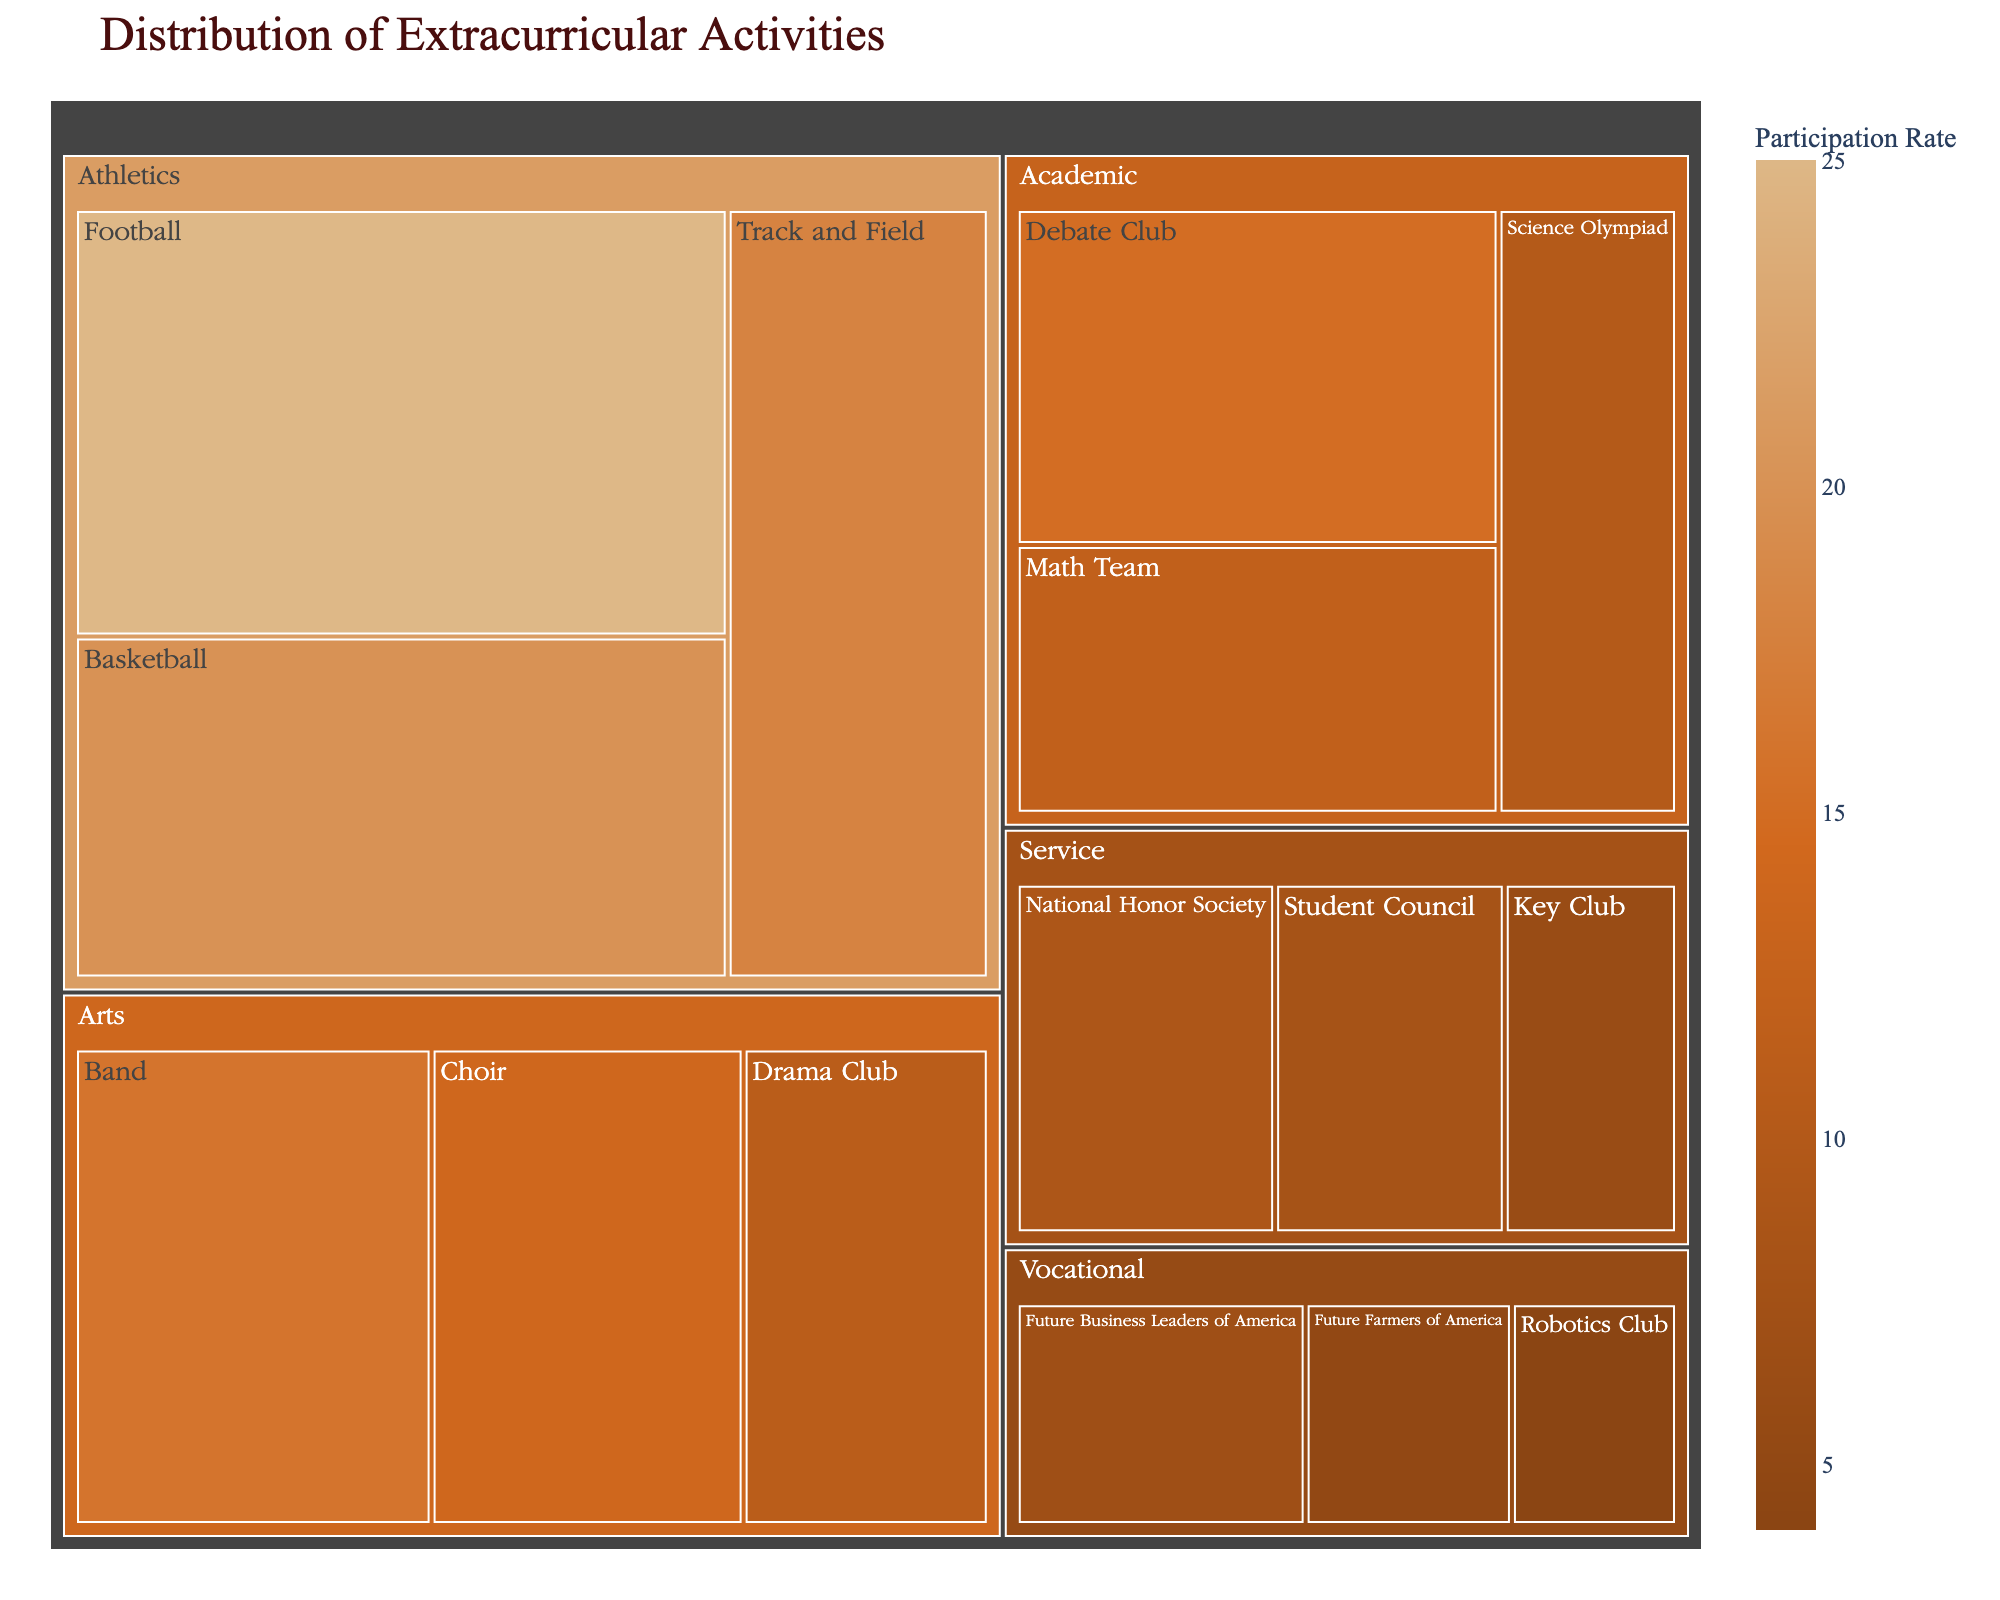What is the title of the treemap? The title of the treemap is typically located at the top of the figure, displaying the subject of the treemap.
Answer: Distribution of Extracurricular Activities Which category has the highest participation rate? One must identify the largest proportional area within the treemap and note its corresponding category. The 'Athletics' category fills the largest portion of the treemap.
Answer: Athletics Out of the Athletic subcategories, which has the highest participation rate? To find the highest participation rate within Athletics, look at the relative sizes of the subcategories under the Athletics section and identify the largest one. Football has the largest area under Athletics.
Answer: Football What is the participation rate for the Drama Club? Locate the Drama Club subcategory within the Arts category on the treemap and refer to the participation rate indicated.
Answer: 11% What is the combined participation rate for the Debate Club and Math Team? Add the participation rates of the Debate Club (15) and Math Team (12) together. 15 + 12 = 27
Answer: 27% Which category has both the largest and smallest subcategories in terms of participation rate? Observe the treemap for the category that contains both the largest (Football in Athletics) and the smallest (Robotics Club in Vocational) areas.
Answer: Vocational Compare the participation rates of Band and Student Council. Which one is higher? Locate both Band under Arts and Student Council under Service, then compare their displayed participation rates. Band has 16%, while Student Council has 8%.
Answer: Band Which color is used to represent the highest participation rates and what is the highest rate? Identify the color range on the treemap, where the darkest/boldest hue denotes the highest rates. The darkest hue represents 25% (Football).
Answer: Darkest (#8B4513), 25% What’s the average participation rate in the Vocational category? Sum the participation rates for all subcategories in Vocational and divide by the number of subcategories. (7 + 5 + 4) / 3 = 16 / 3 = 5.33
Answer: 5.33% Rank the subcategories of Arts from highest to lowest participation rate. Compare the areas corresponding to subcategories within Arts and list them in descending order. Band (16%), Choir (14%), Drama Club (11%).
Answer: Band, Choir, Drama Club 